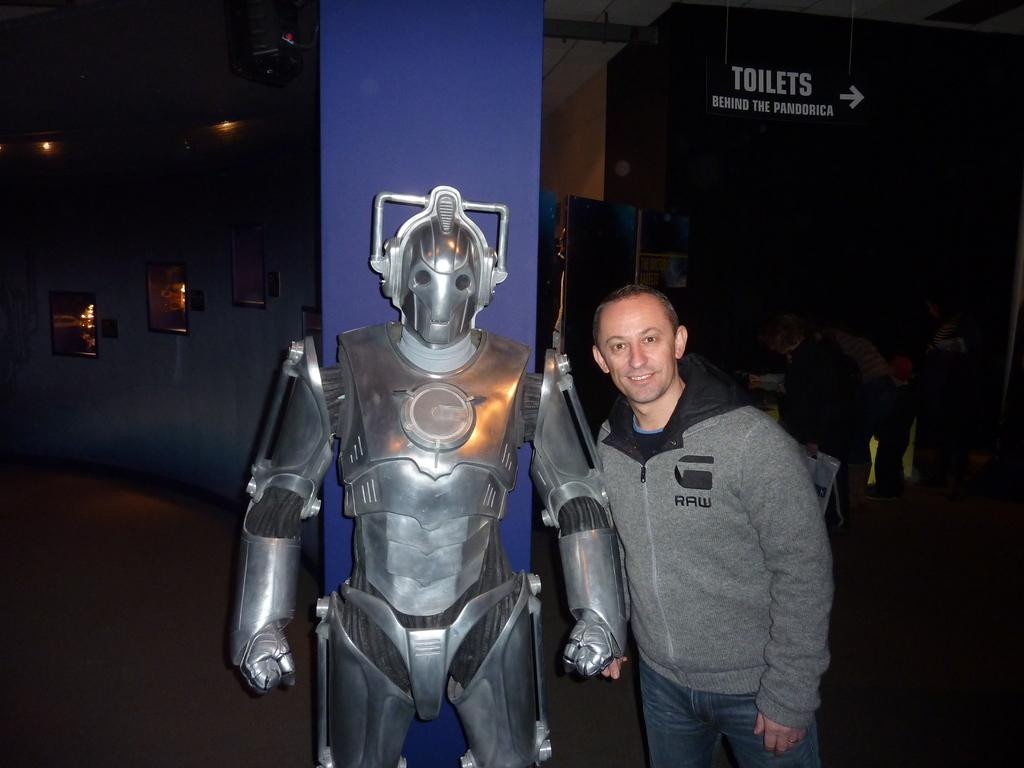What is the person in the image standing beside? The person is standing beside a robot in the image. What is the person wearing in the image? The person is wearing an ash and blue color dress in the image. What can be seen in the background of the image? There are lights visible in the background of the image. What is on the wall in the background of the image? There is a board on the wall in the background of the image. What shape is the snake in the image? There is no snake present in the image. What type of ear is visible on the person in the image? The person's ears are not visible in the image, as they are covered by their hair. 